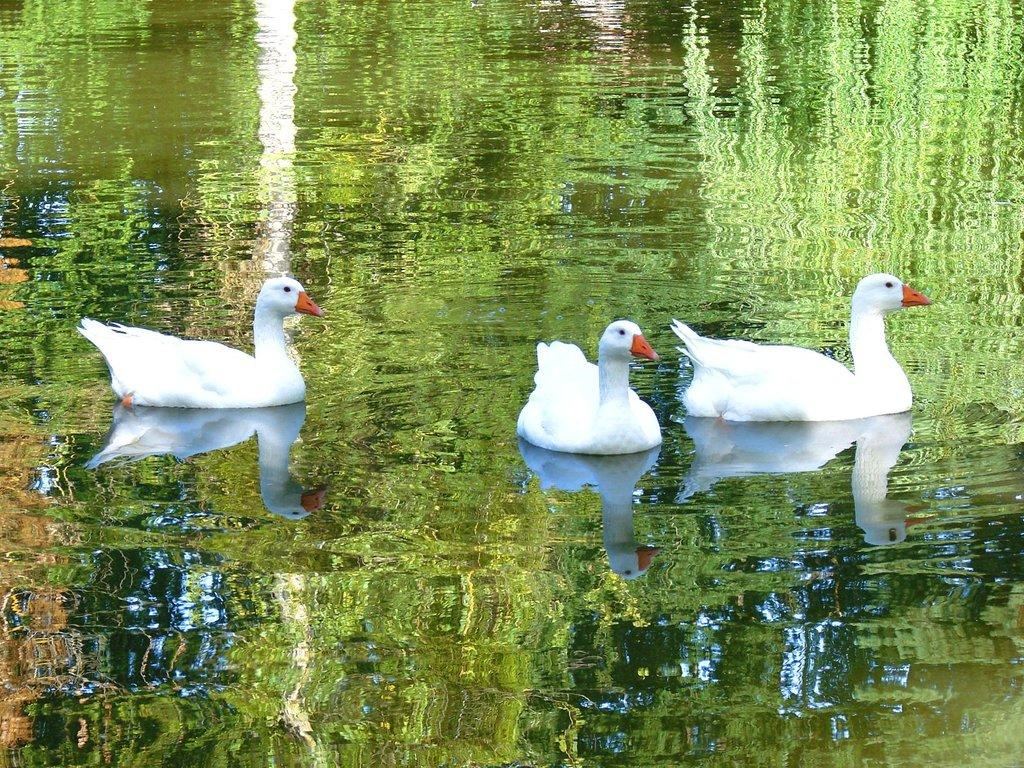How many swans are in the image? There are three swans in the image. What color are the swans? The swans are white in color. What are the swans doing in the image? The swans are swimming in the water. What else can be seen in the image besides the swans? There is water visible in the image, and the reflection of trees and plants is visible in the water. What type of cord is being used by the swans to swim in the image? There is no cord present in the image; the swans are swimming using their own abilities. 